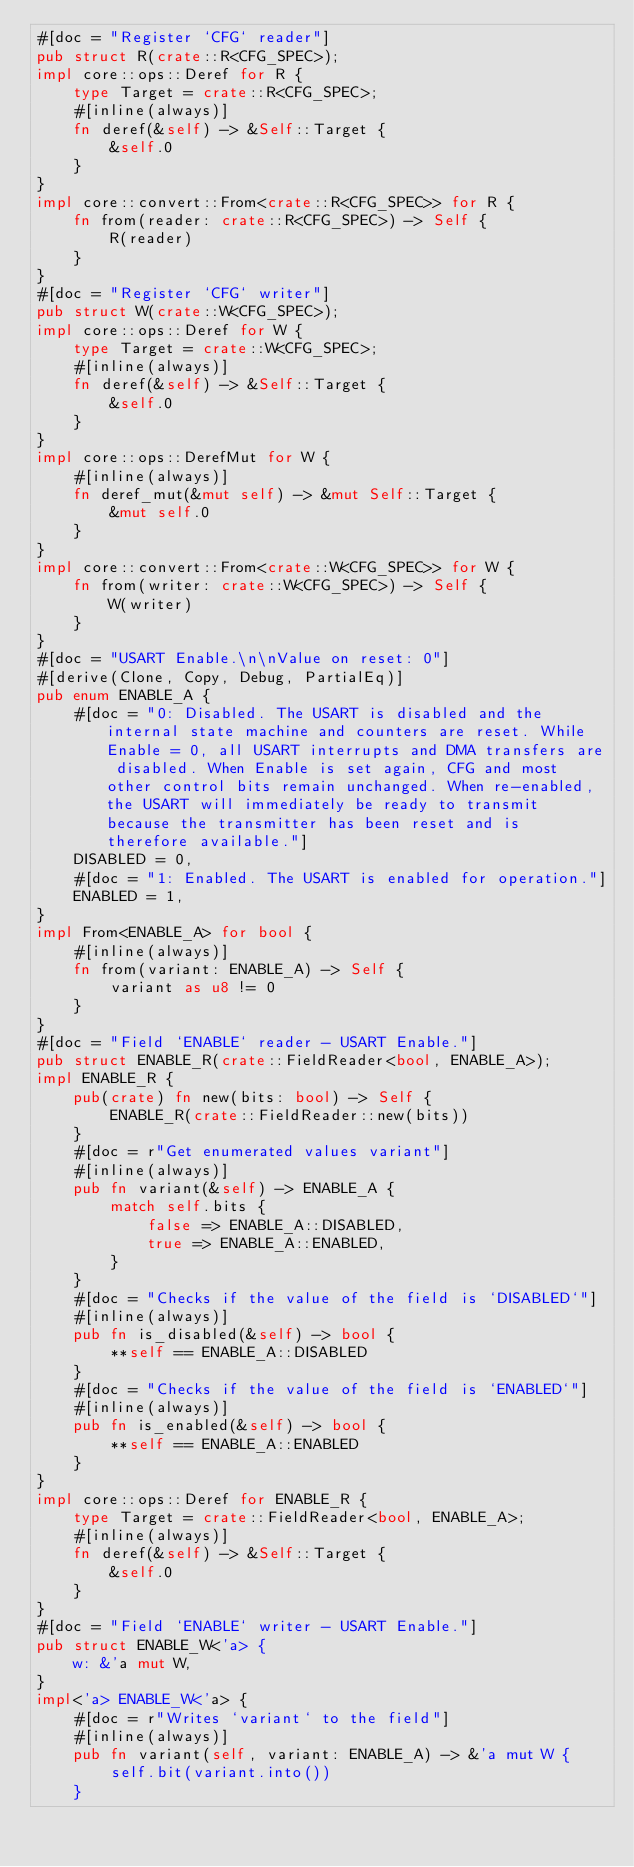Convert code to text. <code><loc_0><loc_0><loc_500><loc_500><_Rust_>#[doc = "Register `CFG` reader"]
pub struct R(crate::R<CFG_SPEC>);
impl core::ops::Deref for R {
    type Target = crate::R<CFG_SPEC>;
    #[inline(always)]
    fn deref(&self) -> &Self::Target {
        &self.0
    }
}
impl core::convert::From<crate::R<CFG_SPEC>> for R {
    fn from(reader: crate::R<CFG_SPEC>) -> Self {
        R(reader)
    }
}
#[doc = "Register `CFG` writer"]
pub struct W(crate::W<CFG_SPEC>);
impl core::ops::Deref for W {
    type Target = crate::W<CFG_SPEC>;
    #[inline(always)]
    fn deref(&self) -> &Self::Target {
        &self.0
    }
}
impl core::ops::DerefMut for W {
    #[inline(always)]
    fn deref_mut(&mut self) -> &mut Self::Target {
        &mut self.0
    }
}
impl core::convert::From<crate::W<CFG_SPEC>> for W {
    fn from(writer: crate::W<CFG_SPEC>) -> Self {
        W(writer)
    }
}
#[doc = "USART Enable.\n\nValue on reset: 0"]
#[derive(Clone, Copy, Debug, PartialEq)]
pub enum ENABLE_A {
    #[doc = "0: Disabled. The USART is disabled and the internal state machine and counters are reset. While Enable = 0, all USART interrupts and DMA transfers are disabled. When Enable is set again, CFG and most other control bits remain unchanged. When re-enabled, the USART will immediately be ready to transmit because the transmitter has been reset and is therefore available."]
    DISABLED = 0,
    #[doc = "1: Enabled. The USART is enabled for operation."]
    ENABLED = 1,
}
impl From<ENABLE_A> for bool {
    #[inline(always)]
    fn from(variant: ENABLE_A) -> Self {
        variant as u8 != 0
    }
}
#[doc = "Field `ENABLE` reader - USART Enable."]
pub struct ENABLE_R(crate::FieldReader<bool, ENABLE_A>);
impl ENABLE_R {
    pub(crate) fn new(bits: bool) -> Self {
        ENABLE_R(crate::FieldReader::new(bits))
    }
    #[doc = r"Get enumerated values variant"]
    #[inline(always)]
    pub fn variant(&self) -> ENABLE_A {
        match self.bits {
            false => ENABLE_A::DISABLED,
            true => ENABLE_A::ENABLED,
        }
    }
    #[doc = "Checks if the value of the field is `DISABLED`"]
    #[inline(always)]
    pub fn is_disabled(&self) -> bool {
        **self == ENABLE_A::DISABLED
    }
    #[doc = "Checks if the value of the field is `ENABLED`"]
    #[inline(always)]
    pub fn is_enabled(&self) -> bool {
        **self == ENABLE_A::ENABLED
    }
}
impl core::ops::Deref for ENABLE_R {
    type Target = crate::FieldReader<bool, ENABLE_A>;
    #[inline(always)]
    fn deref(&self) -> &Self::Target {
        &self.0
    }
}
#[doc = "Field `ENABLE` writer - USART Enable."]
pub struct ENABLE_W<'a> {
    w: &'a mut W,
}
impl<'a> ENABLE_W<'a> {
    #[doc = r"Writes `variant` to the field"]
    #[inline(always)]
    pub fn variant(self, variant: ENABLE_A) -> &'a mut W {
        self.bit(variant.into())
    }</code> 